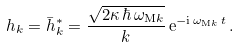<formula> <loc_0><loc_0><loc_500><loc_500>h _ { k } = \bar { h } _ { k } ^ { * } = \frac { \sqrt { 2 \kappa \, \hbar { \, } \omega _ { \mathrm M k } } } { k } \, \mathrm e ^ { - \mathrm i \, \omega _ { \mathrm M k } \, t } \, .</formula> 